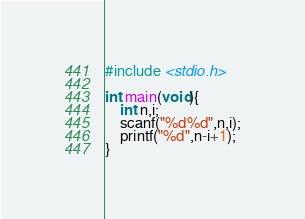Convert code to text. <code><loc_0><loc_0><loc_500><loc_500><_C_>#include <stdio.h>

int main(void){
    int n,i;
    scanf("%d%d",n,i);
    printf("%d",n-i+1);
}</code> 